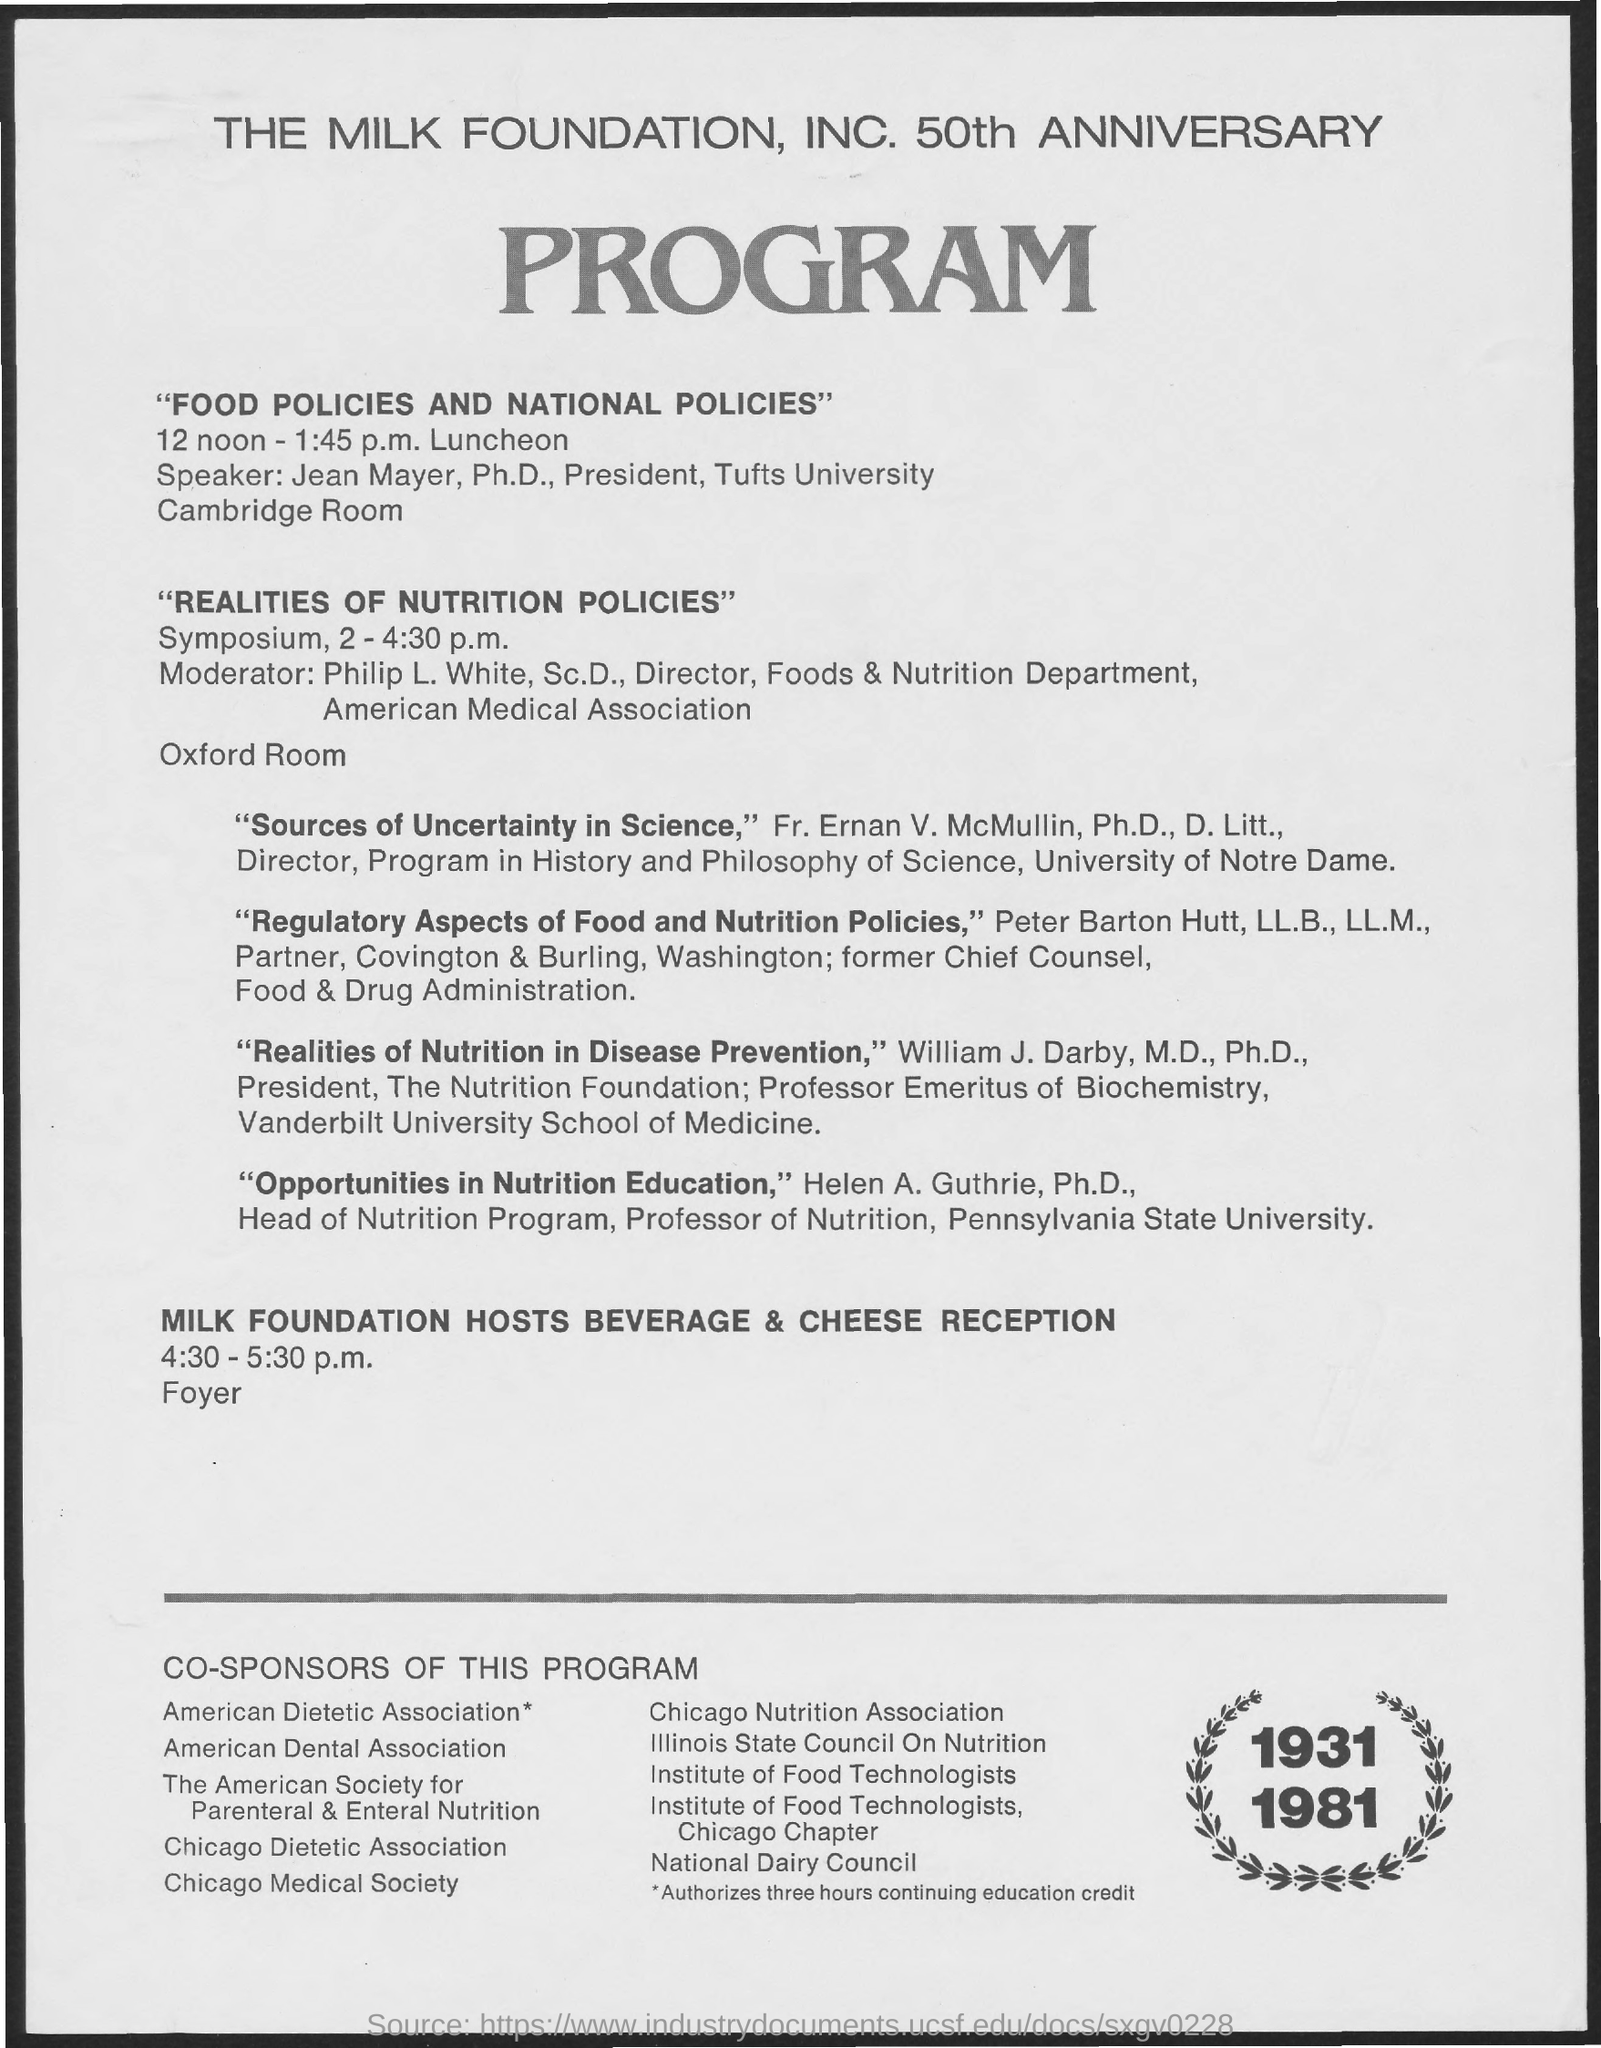Mention a couple of crucial points in this snapshot. Jean Mayer, Ph.D., is the speaker of food policies and national policies. The timings for the Milk Foundation Hosts Beverage & Cheese Reception are from 4:30 to 5:30 pm. 